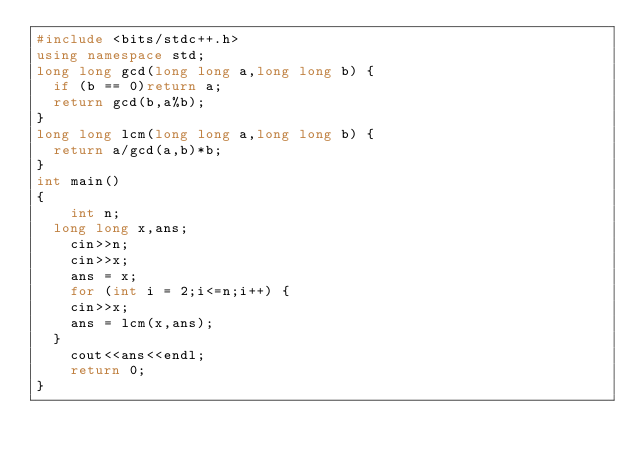Convert code to text. <code><loc_0><loc_0><loc_500><loc_500><_C++_>#include <bits/stdc++.h>
using namespace std;
long long gcd(long long a,long long b) {
	if (b == 0)return a;
	return gcd(b,a%b);
}
long long lcm(long long a,long long b) {
	return a/gcd(a,b)*b;
}
int main()
{
    int n;
	long long x,ans;
    cin>>n;
    cin>>x;
    ans = x;
    for (int i = 2;i<=n;i++) {
		cin>>x;
		ans = lcm(x,ans);
	}
    cout<<ans<<endl;
    return 0;
}</code> 